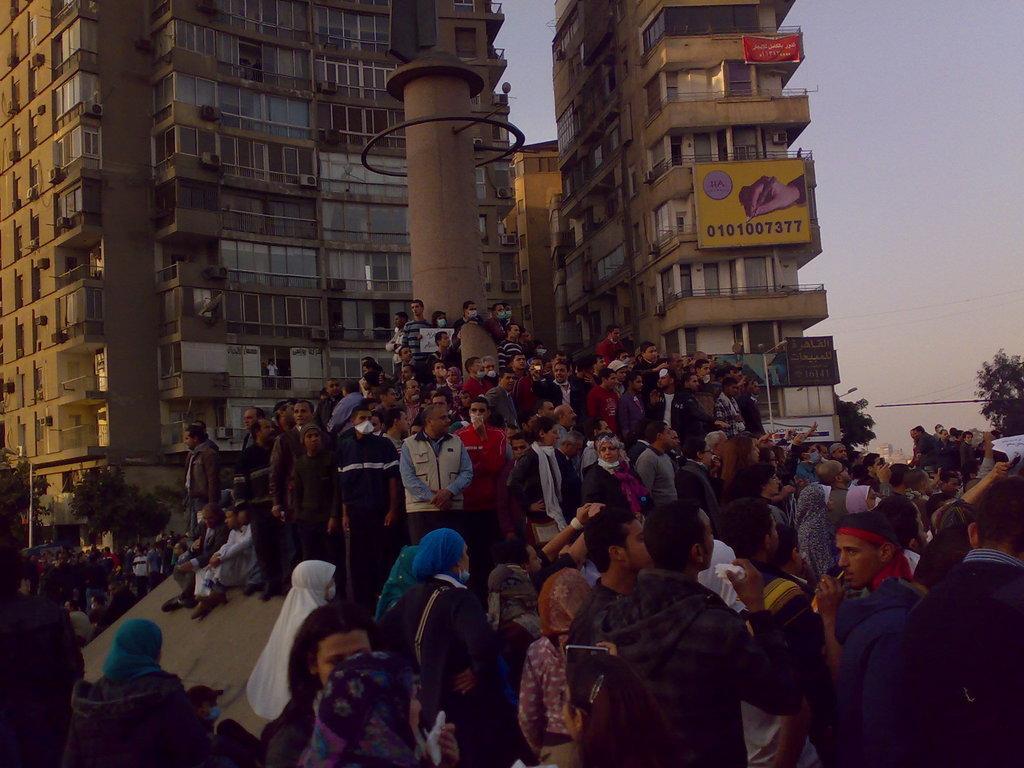Could you give a brief overview of what you see in this image? In this image in the center there are a group of people standing, and some of them are holding somethings and there is a pipe. And in the background there are buildings, hoardings, banner, railing, trees and wires. At the top of the image there is sky. 